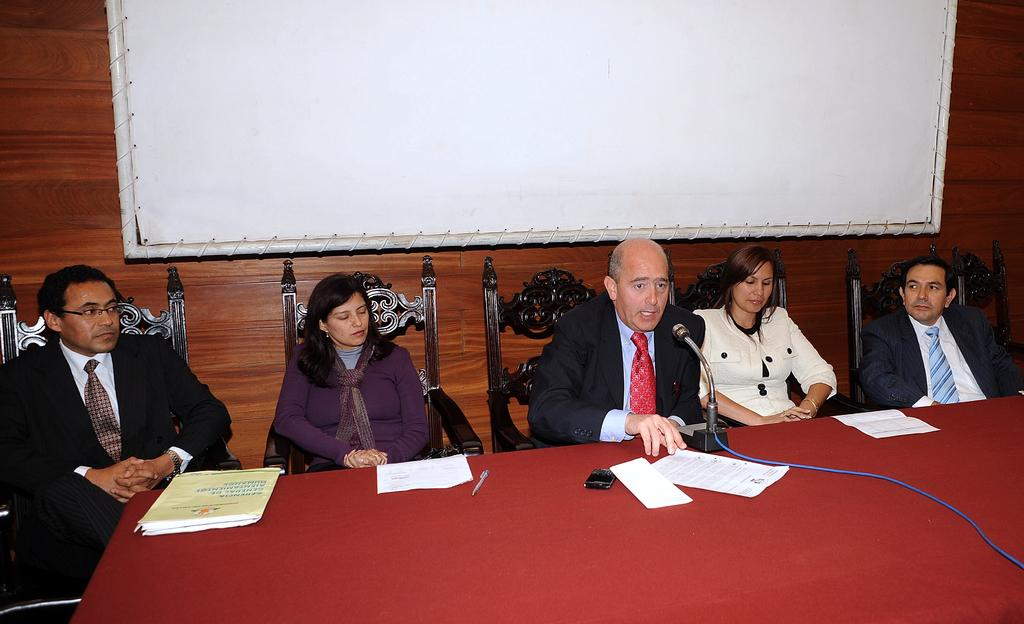What are the people in the image doing? The people in the image are sitting on chairs. What is present in the image that the people might be using? There is a table in the image that the people might be using. What can be seen in the background of the image? There is a screen and a wooden wall in the background of the image. What type of locket is hanging from the wooden wall in the image? There is no locket present in the image; only a screen and a wooden wall are visible in the background. 